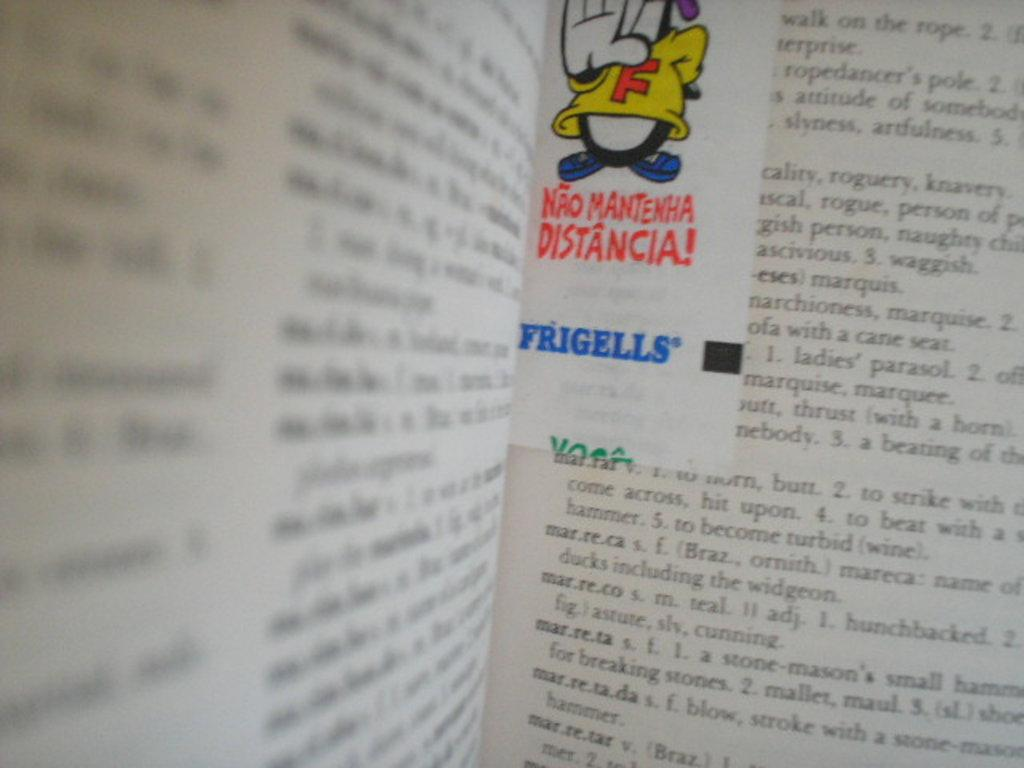<image>
Render a clear and concise summary of the photo. An open book in a foreign language including Frigells. 